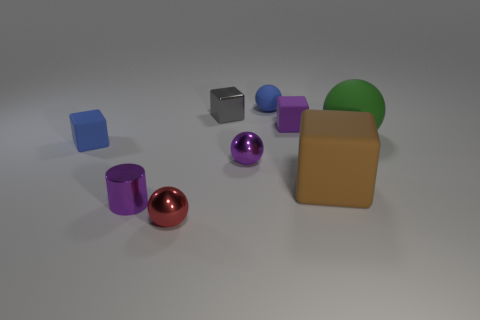Subtract 2 spheres. How many spheres are left? 2 Subtract all tiny blue rubber balls. How many balls are left? 3 Subtract all blue blocks. How many blocks are left? 3 Subtract all red blocks. Subtract all brown cylinders. How many blocks are left? 4 Add 1 tiny red metallic balls. How many objects exist? 10 Subtract all balls. How many objects are left? 5 Subtract 0 yellow blocks. How many objects are left? 9 Subtract all yellow rubber balls. Subtract all tiny spheres. How many objects are left? 6 Add 4 purple metal spheres. How many purple metal spheres are left? 5 Add 7 tiny purple matte objects. How many tiny purple matte objects exist? 8 